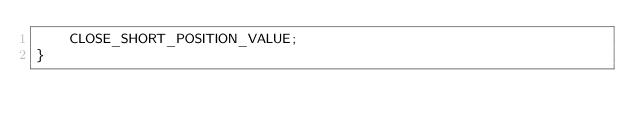Convert code to text. <code><loc_0><loc_0><loc_500><loc_500><_Java_>    CLOSE_SHORT_POSITION_VALUE;
}
</code> 